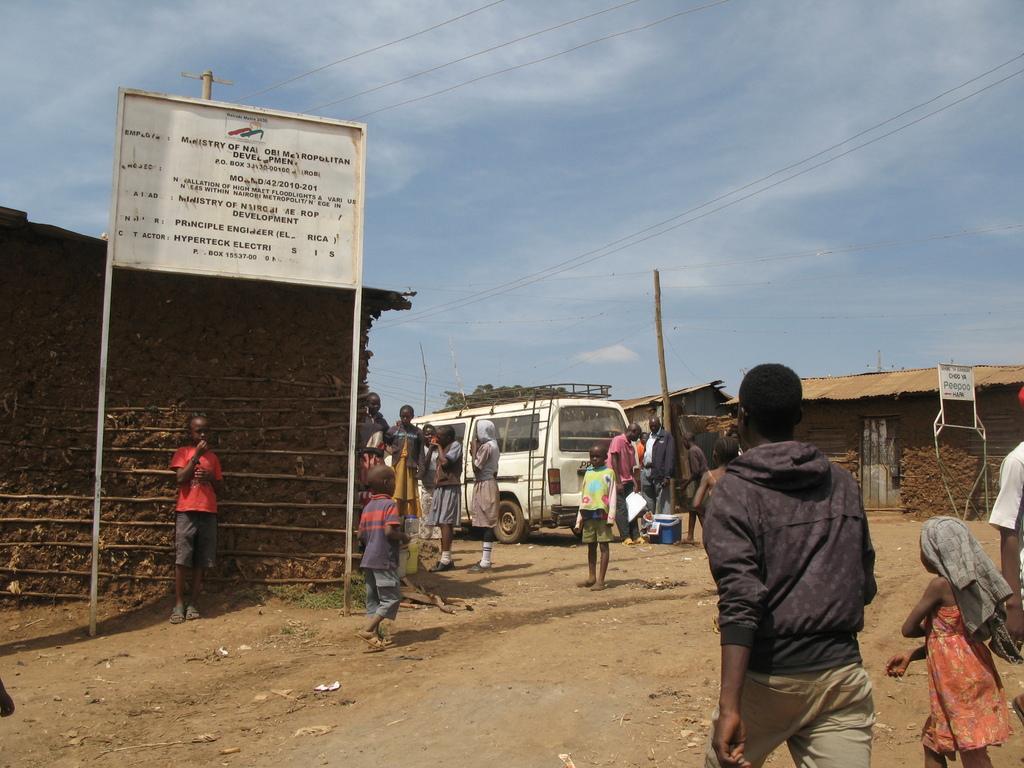Please provide a concise description of this image. This picture describes about group of people, few are standing and few are walking, in front of them we can see few houses, poles and notice boards, and also we can see a van and a box. 